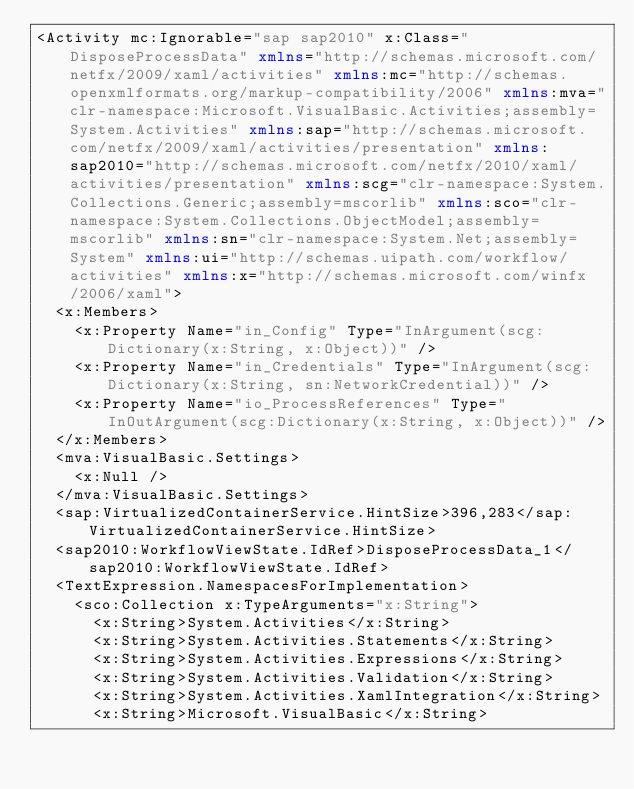Convert code to text. <code><loc_0><loc_0><loc_500><loc_500><_XML_><Activity mc:Ignorable="sap sap2010" x:Class="DisposeProcessData" xmlns="http://schemas.microsoft.com/netfx/2009/xaml/activities" xmlns:mc="http://schemas.openxmlformats.org/markup-compatibility/2006" xmlns:mva="clr-namespace:Microsoft.VisualBasic.Activities;assembly=System.Activities" xmlns:sap="http://schemas.microsoft.com/netfx/2009/xaml/activities/presentation" xmlns:sap2010="http://schemas.microsoft.com/netfx/2010/xaml/activities/presentation" xmlns:scg="clr-namespace:System.Collections.Generic;assembly=mscorlib" xmlns:sco="clr-namespace:System.Collections.ObjectModel;assembly=mscorlib" xmlns:sn="clr-namespace:System.Net;assembly=System" xmlns:ui="http://schemas.uipath.com/workflow/activities" xmlns:x="http://schemas.microsoft.com/winfx/2006/xaml">
  <x:Members>
    <x:Property Name="in_Config" Type="InArgument(scg:Dictionary(x:String, x:Object))" />
    <x:Property Name="in_Credentials" Type="InArgument(scg:Dictionary(x:String, sn:NetworkCredential))" />
    <x:Property Name="io_ProcessReferences" Type="InOutArgument(scg:Dictionary(x:String, x:Object))" />
  </x:Members>
  <mva:VisualBasic.Settings>
    <x:Null />
  </mva:VisualBasic.Settings>
  <sap:VirtualizedContainerService.HintSize>396,283</sap:VirtualizedContainerService.HintSize>
  <sap2010:WorkflowViewState.IdRef>DisposeProcessData_1</sap2010:WorkflowViewState.IdRef>
  <TextExpression.NamespacesForImplementation>
    <sco:Collection x:TypeArguments="x:String">
      <x:String>System.Activities</x:String>
      <x:String>System.Activities.Statements</x:String>
      <x:String>System.Activities.Expressions</x:String>
      <x:String>System.Activities.Validation</x:String>
      <x:String>System.Activities.XamlIntegration</x:String>
      <x:String>Microsoft.VisualBasic</x:String></code> 